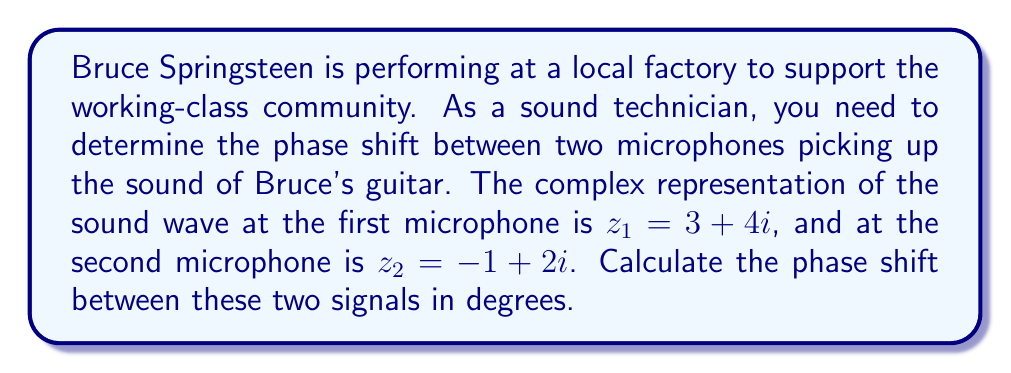Can you solve this math problem? To determine the phase shift between two complex numbers representing sound waves, we need to follow these steps:

1) The phase of a complex number $z = a + bi$ is given by $\theta = \arctan(\frac{b}{a})$.

2) For $z_1 = 3 + 4i$:
   $\theta_1 = \arctan(\frac{4}{3}) \approx 0.9273$ radians

3) For $z_2 = -1 + 2i$:
   $\theta_2 = \arctan(\frac{2}{-1}) + \pi \approx 2.0344$ radians
   (We add $\pi$ because the real part is negative, placing this in the 2nd quadrant)

4) The phase shift is the difference between these phases:
   $\Delta\theta = \theta_2 - \theta_1 \approx 2.0344 - 0.9273 = 1.1071$ radians

5) Convert radians to degrees:
   $\Delta\theta_{degrees} = \Delta\theta_{radians} \times \frac{180^{\circ}}{\pi} \approx 63.4349^{\circ}$

Therefore, the phase shift between the two microphones is approximately 63.43°.
Answer: $63.43^{\circ}$ 